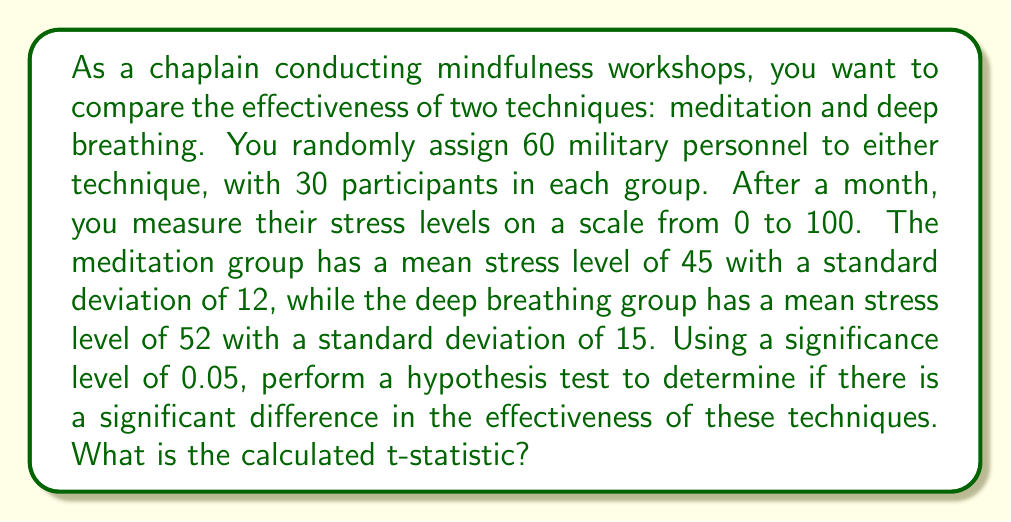Solve this math problem. Let's approach this step-by-step:

1) First, we need to set up our hypotheses:
   $H_0: \mu_1 = \mu_2$ (null hypothesis: no difference between techniques)
   $H_a: \mu_1 \neq \mu_2$ (alternative hypothesis: there is a difference)

2) We're dealing with two independent samples, so we'll use a two-sample t-test.

3) The formula for the t-statistic is:

   $$t = \frac{\bar{x}_1 - \bar{x}_2}{\sqrt{\frac{s_1^2}{n_1} + \frac{s_2^2}{n_2}}}$$

   Where:
   $\bar{x}_1$ and $\bar{x}_2$ are the sample means
   $s_1$ and $s_2$ are the sample standard deviations
   $n_1$ and $n_2$ are the sample sizes

4) Let's plug in our values:
   $\bar{x}_1 = 45$ (meditation group mean)
   $\bar{x}_2 = 52$ (deep breathing group mean)
   $s_1 = 12$ (meditation group standard deviation)
   $s_2 = 15$ (deep breathing group standard deviation)
   $n_1 = n_2 = 30$ (sample sizes)

5) Now we can calculate:

   $$t = \frac{45 - 52}{\sqrt{\frac{12^2}{30} + \frac{15^2}{30}}}$$

6) Simplifying:

   $$t = \frac{-7}{\sqrt{\frac{144}{30} + \frac{225}{30}}} = \frac{-7}{\sqrt{4.8 + 7.5}} = \frac{-7}{\sqrt{12.3}}$$

7) Final calculation:

   $$t = \frac{-7}{3.507} \approx -1.996$$
Answer: $-1.996$ 